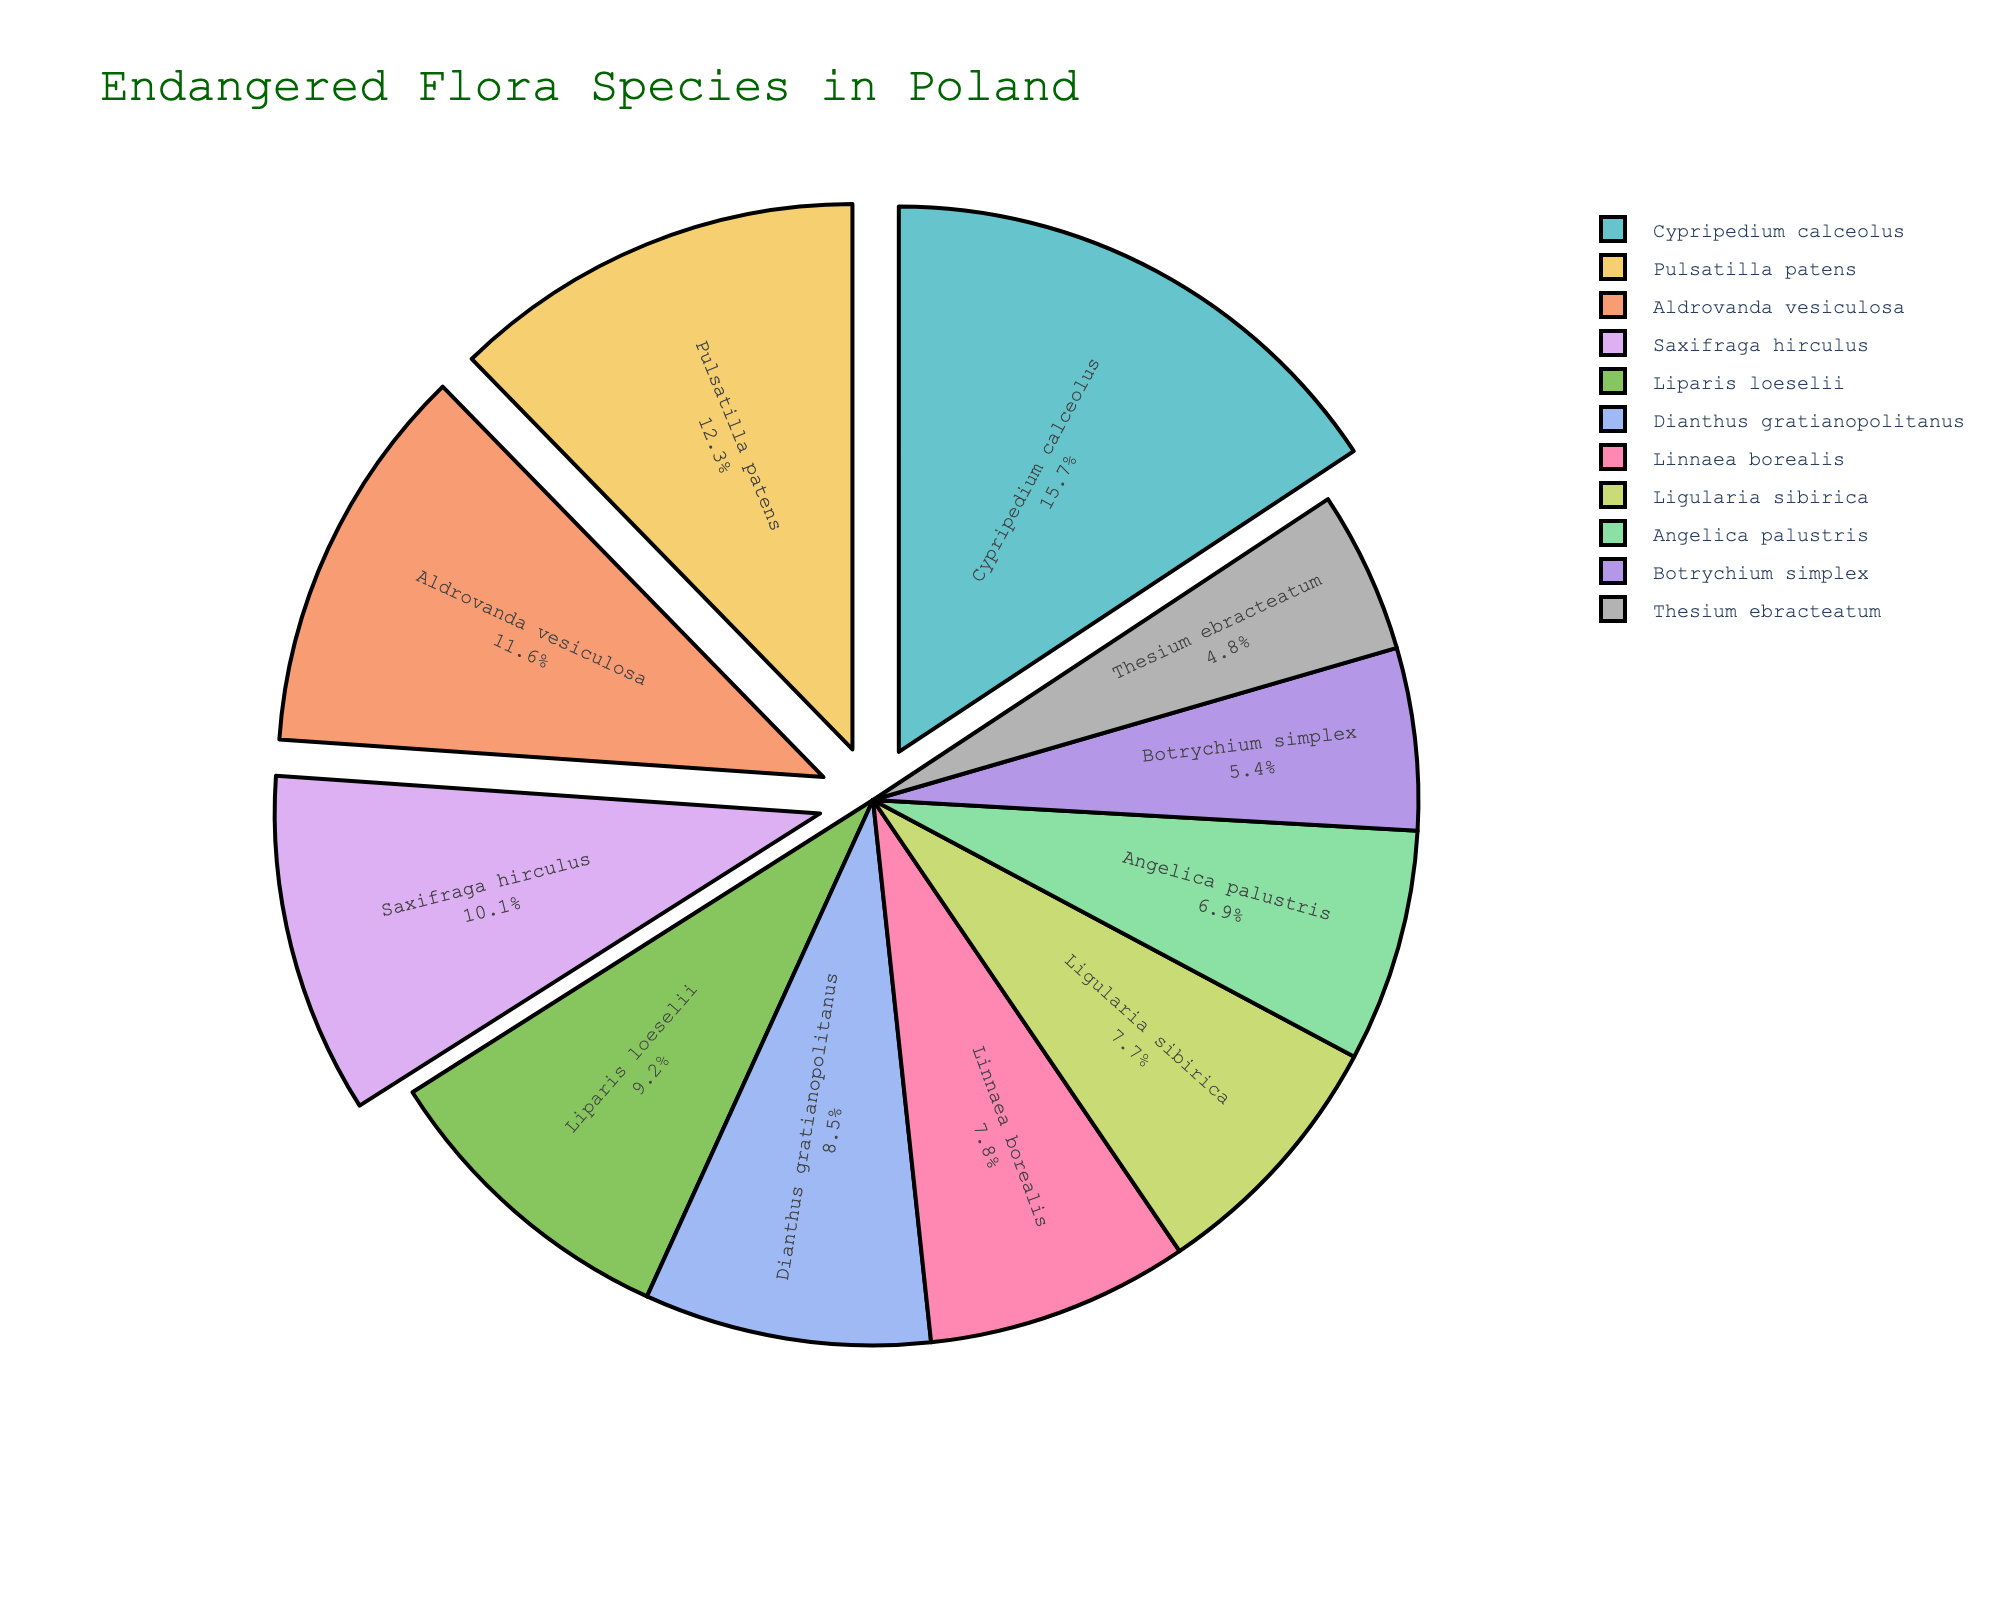What is the species with the highest percentage of endangered flora in Poland? By looking at the figure, identify the segment with the largest proportion or label indicating the highest percentage.
Answer: Cypripedium calceolus Which species has the lowest percentage of endangered flora in Poland? By examining the smallest segment or the one with the lowest percentage label in the pie chart.
Answer: Thesium ebracteatum How does the percentage of Angelica palustris compare to Liparis loeselii? Locate the segments for Angelica palustris and Liparis loeselii and compare their respective percentages from the labels.
Answer: Angelica palustris has a lower percentage (6.9%) than Liparis loeselii (9.2%) What is the combined percentage of Pulsatilla patens and Aldrovanda vesiculosa? Find the segments for Pulsatilla patens and Aldrovanda vesiculosa, add their percentages together: 12.3% + 11.6% = 23.9%.
Answer: 23.9% Which species have percentages over 10%? Identify and list all the segments with labels showing percentages over 10%.
Answer: Cypripedium calceolus, Pulsatilla patens, Aldrovanda vesiculosa, Saxifraga hirculus Compare the percentage difference between Dianthus gratianopolitanus and Botrychium simplex. Find and subtract the percentage of Botrychium simplex from Dianthus gratianopolitanus: 8.5% - 5.4% = 3.1%.
Answer: 3.1% Which species are pulled out from the pie chart? By observing the visual depiction, identify which segments appear to be pulled out. These will have more than 10% according to the setup in the code.
Answer: Cypripedium calceolus, Pulsatilla patens, Aldrovanda vesiculosa, Saxifraga hirculus What is the total percentage of species marked with less than 8%? Sum up the percentages of species with less than 8%: Angelica palustris (6.9%), Linnaea borealis (7.8%), Botrychium simplex (5.4%), Thesium ebracteatum (4.8%), Ligularia sibirica (7.7%): 6.9% + 7.8% + 5.4% + 4.8% + 7.7% = 32.6%.
Answer: 32.6% How does Linnaea borealis compare to Ligularia sibirica in terms of percentage? By examining their respective segments and comparing their percentages: Linnaea borealis (7.8%) and Ligularia sibirica (7.7%).
Answer: Linnaea borealis has a slightly higher percentage than Ligularia sibirica What is the average percentage of the species represented in the pie chart? Add all percentages together and divide by the number of species: (8.5 + 12.3 + 15.7 + 6.9 + 9.2 + 7.8 + 5.4 + 11.6 + 10.1 + 4.8 + 7.7) / 11 = 100 / 11 ≈ 9.09%.
Answer: 9.09% 